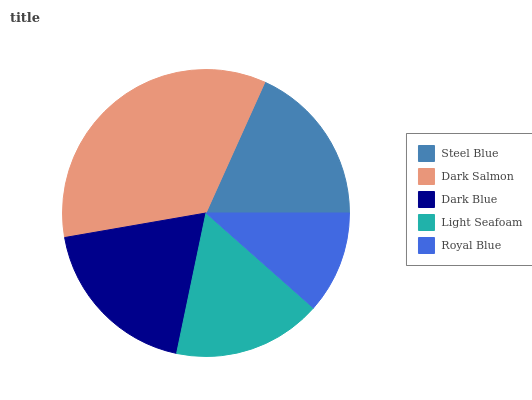Is Royal Blue the minimum?
Answer yes or no. Yes. Is Dark Salmon the maximum?
Answer yes or no. Yes. Is Dark Blue the minimum?
Answer yes or no. No. Is Dark Blue the maximum?
Answer yes or no. No. Is Dark Salmon greater than Dark Blue?
Answer yes or no. Yes. Is Dark Blue less than Dark Salmon?
Answer yes or no. Yes. Is Dark Blue greater than Dark Salmon?
Answer yes or no. No. Is Dark Salmon less than Dark Blue?
Answer yes or no. No. Is Steel Blue the high median?
Answer yes or no. Yes. Is Steel Blue the low median?
Answer yes or no. Yes. Is Royal Blue the high median?
Answer yes or no. No. Is Light Seafoam the low median?
Answer yes or no. No. 